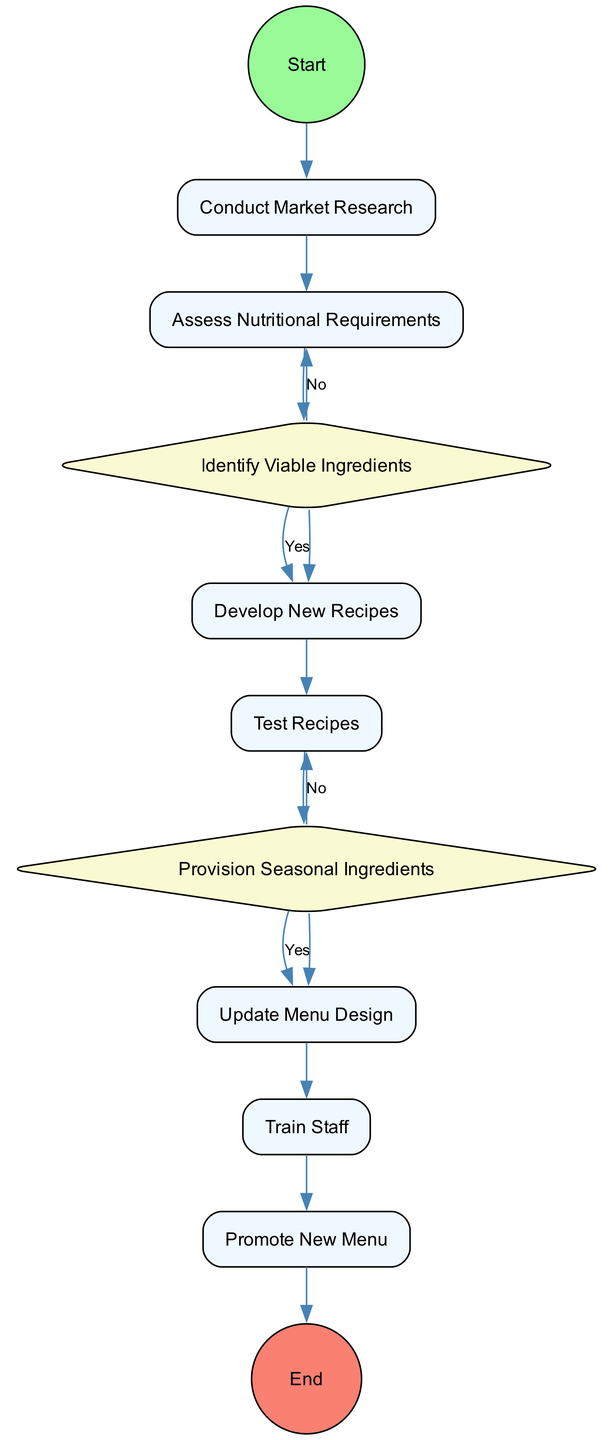What is the first activity in the process? The first activity after the start event is "Conduct Market Research." It directly follows the "Initiate Seasonal Menu Change" start event based on the flow of the diagram.
Answer: Conduct Market Research How many decision nodes are in the diagram? There are two decision nodes in the diagram: "Identify Viable Ingredients" and "Provision Seasonal Ingredients." Each of these nodes represents a point where a decision must be made in the process.
Answer: 2 What is the last activity before the end event? The last activity before the end event is "Promote New Menu." It is connected directly to the end event, indicating that the process concludes after this activity.
Answer: Promote New Menu What happens after "Test Recipes" if the results are satisfactory? If the results of "Test Recipes" are satisfactory, the flow proceeds to the "Provision Seasonal Ingredients" decision node. This means that the next step involves checking the availability and cost of seasonal ingredients.
Answer: Provision Seasonal Ingredients What is the outcome if there is a 'No' decision at "Identify Viable Ingredients"? If the result is 'No' at "Identify Viable Ingredients," the process does not move forward to develop new recipes, and the decision indicates the ingredients did not meet the required standards.
Answer: End process How many activities are included in the diagram? The diagram includes a total of six activities: "Conduct Market Research," "Assess Nutritional Requirements," "Develop New Recipes," "Test Recipes," "Update Menu Design," and "Train Staff." These activities represent key tasks needed for the process.
Answer: 6 